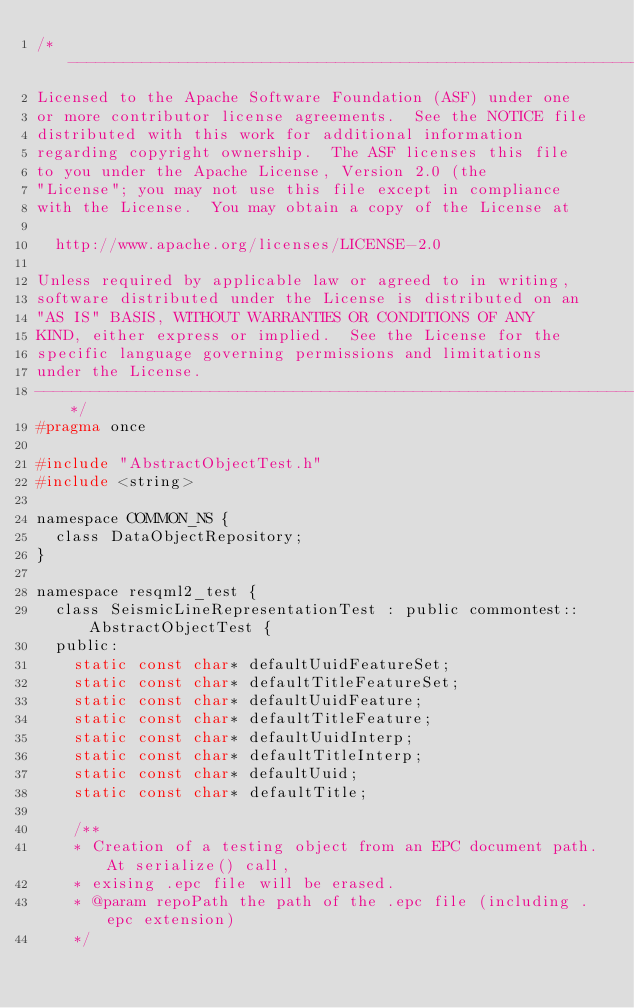<code> <loc_0><loc_0><loc_500><loc_500><_C_>/*-----------------------------------------------------------------------
Licensed to the Apache Software Foundation (ASF) under one
or more contributor license agreements.  See the NOTICE file
distributed with this work for additional information
regarding copyright ownership.  The ASF licenses this file
to you under the Apache License, Version 2.0 (the
"License"; you may not use this file except in compliance
with the License.  You may obtain a copy of the License at

  http://www.apache.org/licenses/LICENSE-2.0

Unless required by applicable law or agreed to in writing,
software distributed under the License is distributed on an
"AS IS" BASIS, WITHOUT WARRANTIES OR CONDITIONS OF ANY
KIND, either express or implied.  See the License for the
specific language governing permissions and limitations
under the License.
-----------------------------------------------------------------------*/
#pragma once

#include "AbstractObjectTest.h"
#include <string>

namespace COMMON_NS {
	class DataObjectRepository;
}

namespace resqml2_test {
	class SeismicLineRepresentationTest : public commontest::AbstractObjectTest {
	public:
		static const char* defaultUuidFeatureSet;
		static const char* defaultTitleFeatureSet;
		static const char* defaultUuidFeature;
		static const char* defaultTitleFeature;
		static const char* defaultUuidInterp;
		static const char* defaultTitleInterp;
		static const char* defaultUuid;
		static const char* defaultTitle;

		/**
		* Creation of a testing object from an EPC document path. At serialize() call,
		* exising .epc file will be erased. 
		* @param repoPath the path of the .epc file (including .epc extension)
		*/</code> 